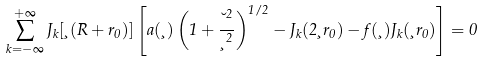Convert formula to latex. <formula><loc_0><loc_0><loc_500><loc_500>\sum _ { k = - \infty } ^ { + \infty } J _ { k } [ \xi ( R + r _ { 0 } ) ] \left [ a ( \xi ) \left ( 1 + \frac { \lambda ^ { 2 } } { \xi ^ { 2 } } \right ) ^ { 1 / 2 } - J _ { k } ( 2 \xi r _ { 0 } ) - f ( \xi ) J _ { k } ( \xi r _ { 0 } ) \right ] = 0</formula> 